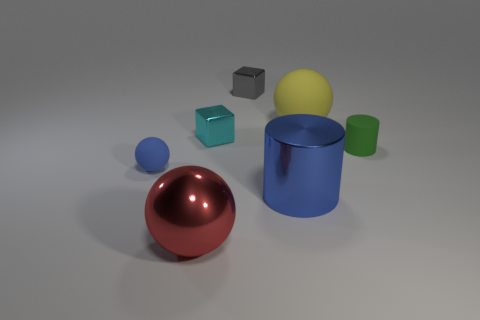What materials appear to be represented in the objects shown? The objects seem to represent various materials, including what looks like shiny, reflective metal for the sphere and the small cube, a glossy plastic or rubber material for the cylindrical objects, and a matte metal or plastic for the block behind the sphere. 